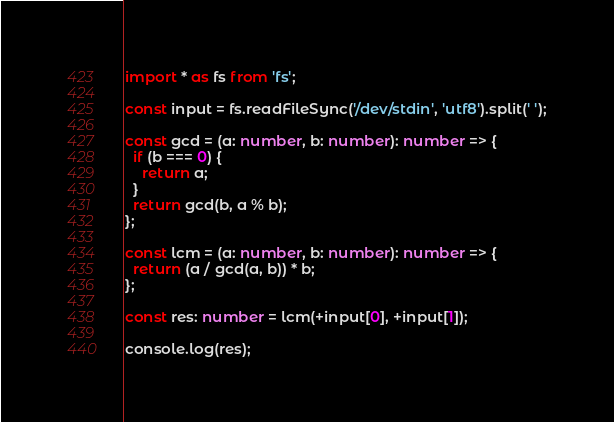<code> <loc_0><loc_0><loc_500><loc_500><_TypeScript_>import * as fs from 'fs';

const input = fs.readFileSync('/dev/stdin', 'utf8').split(' ');

const gcd = (a: number, b: number): number => {
  if (b === 0) {
    return a;
  }
  return gcd(b, a % b);
};

const lcm = (a: number, b: number): number => {
  return (a / gcd(a, b)) * b;
};

const res: number = lcm(+input[0], +input[1]);

console.log(res);
</code> 